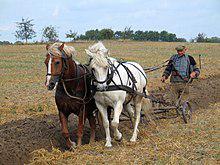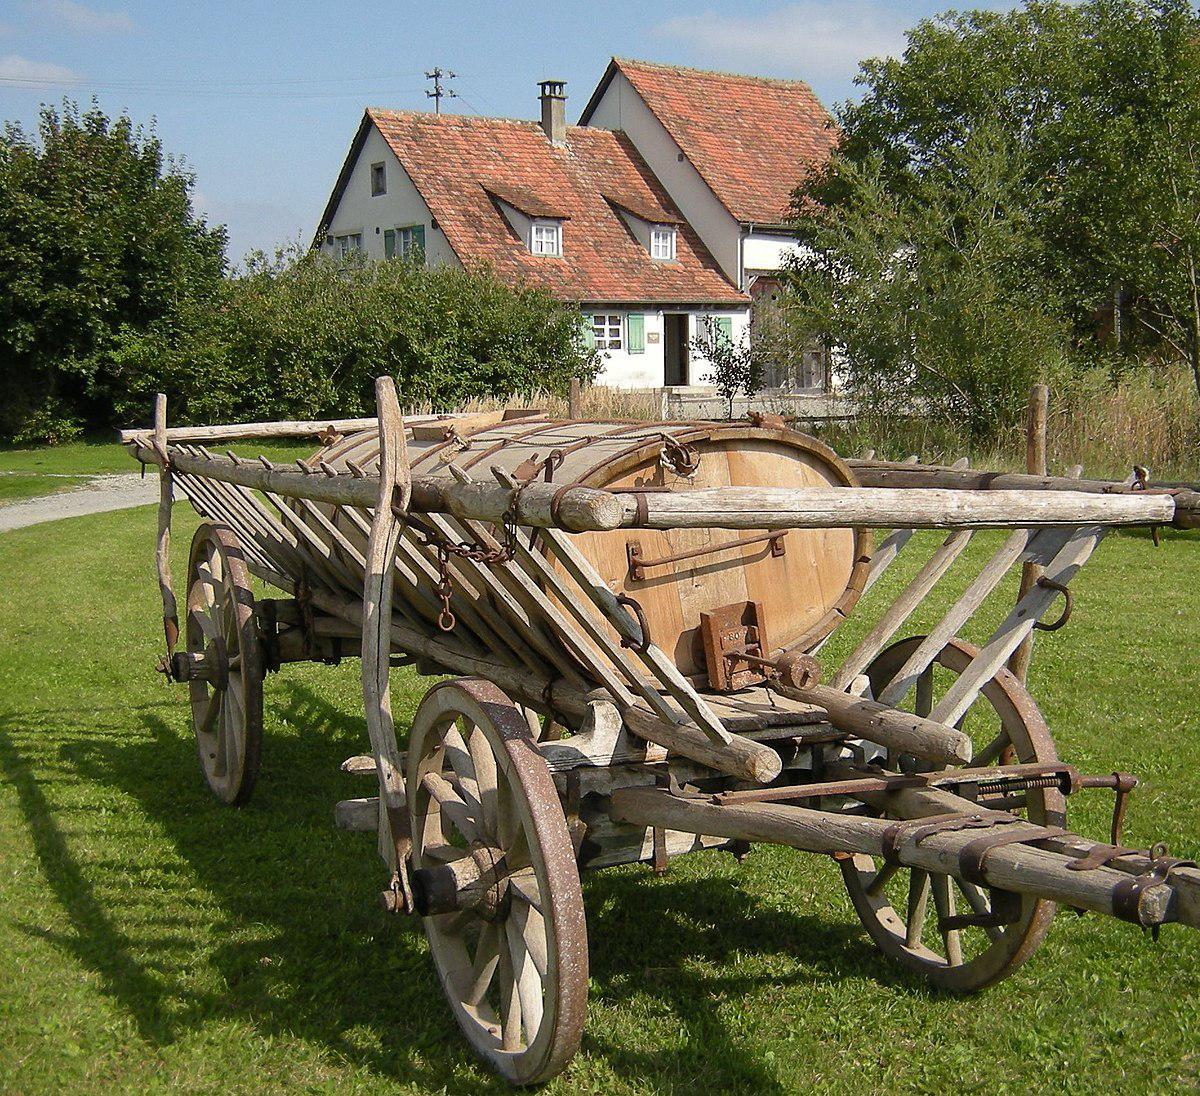The first image is the image on the left, the second image is the image on the right. Considering the images on both sides, is "An image shows two side-by-side horses pulling some type of wheeled thing steered by a man." valid? Answer yes or no. Yes. The first image is the image on the left, the second image is the image on the right. Examine the images to the left and right. Is the description "The wagon in the image on the right is not attached to a horse." accurate? Answer yes or no. Yes. 